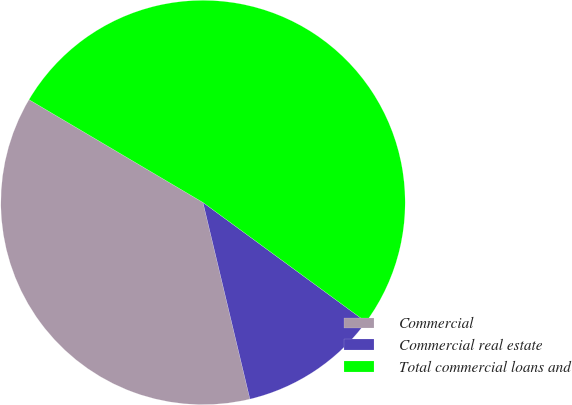Convert chart to OTSL. <chart><loc_0><loc_0><loc_500><loc_500><pie_chart><fcel>Commercial<fcel>Commercial real estate<fcel>Total commercial loans and<nl><fcel>37.23%<fcel>11.21%<fcel>51.57%<nl></chart> 